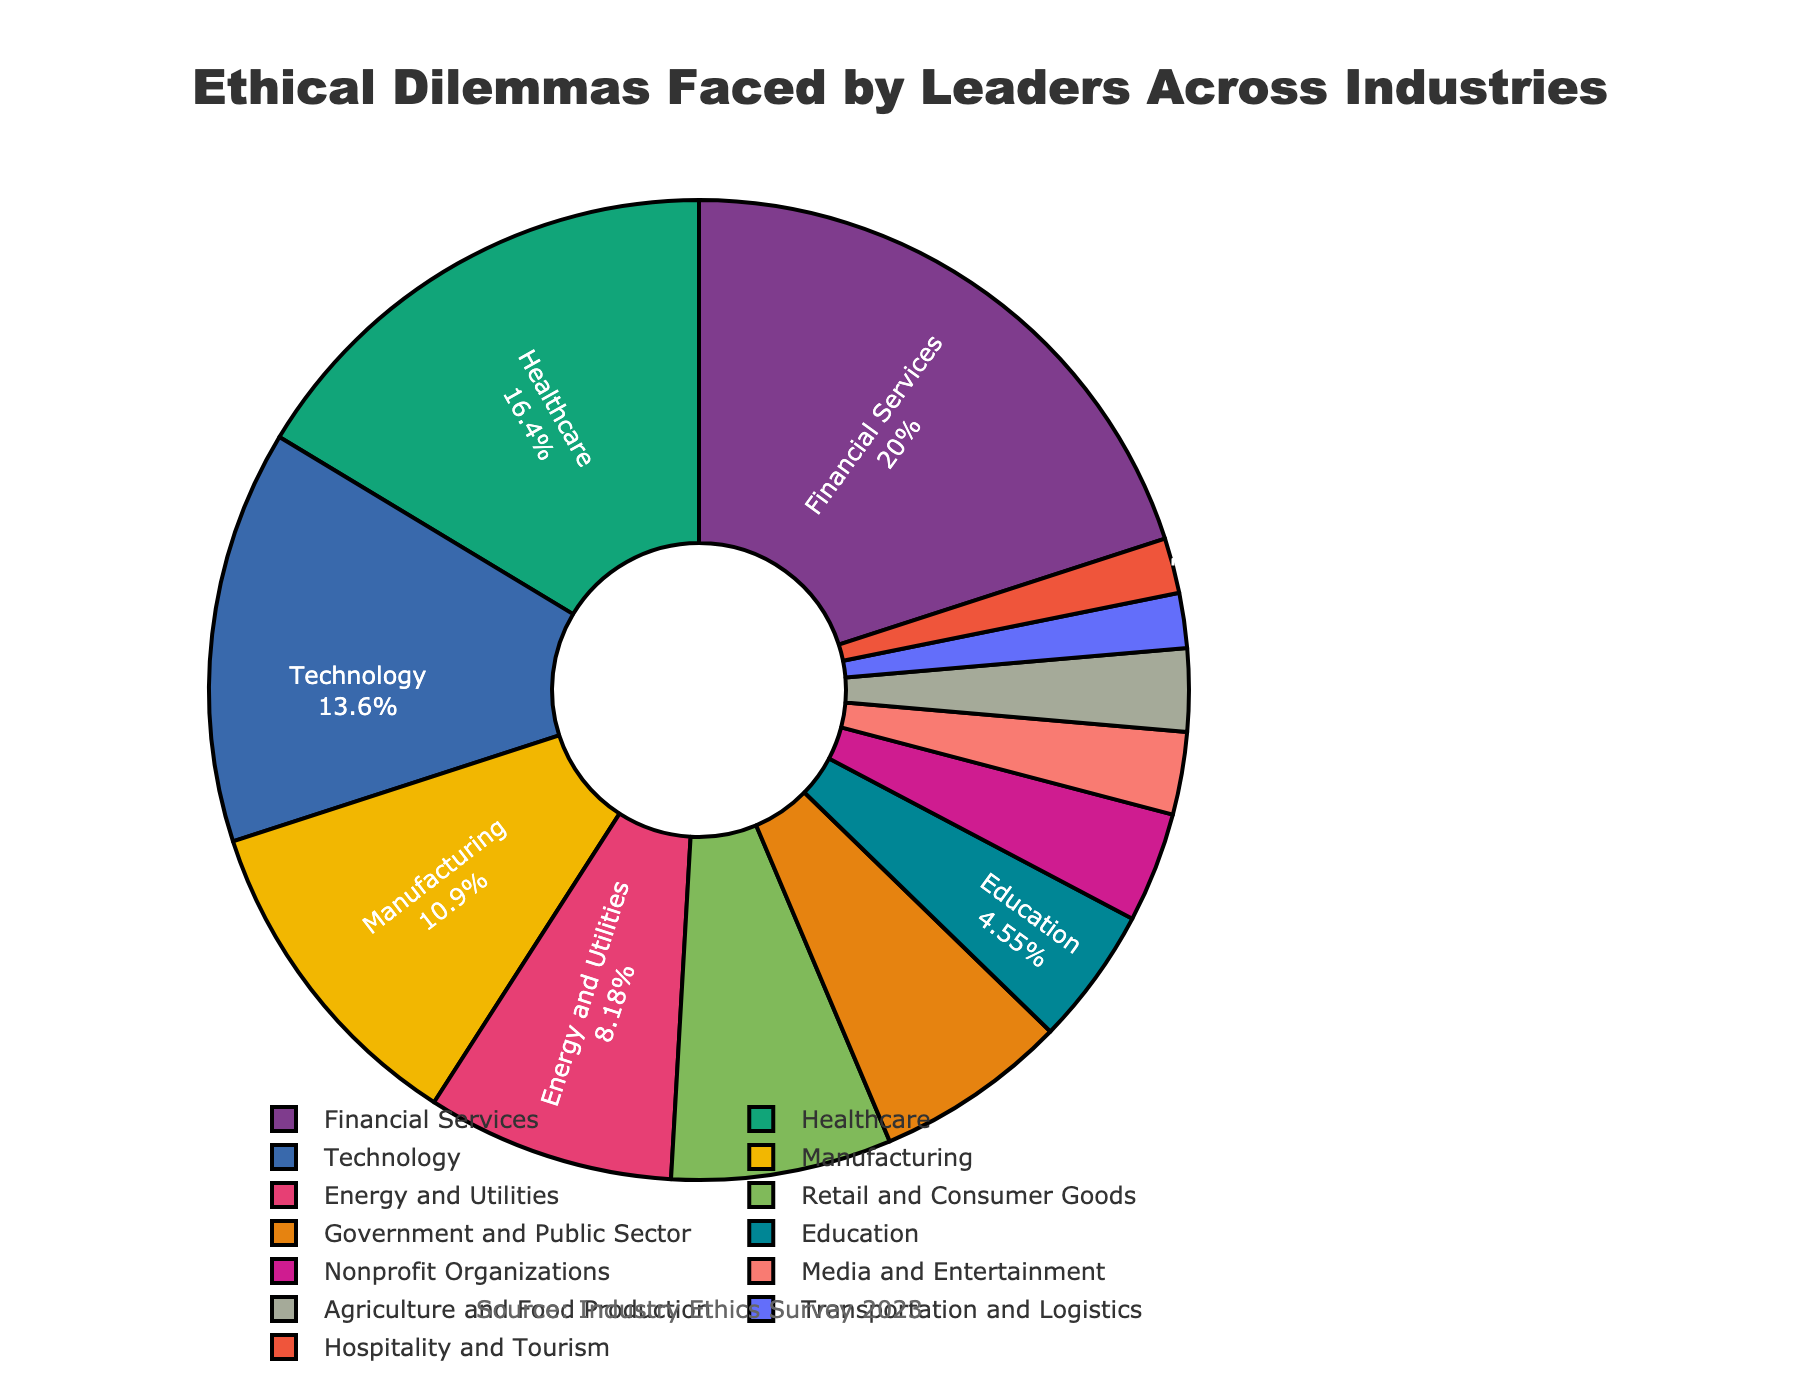Which industry sector faces the highest percentage of ethical dilemmas? The sector with the largest slice in the pie chart represents the highest percentage. By visual inspection, the Financial Services sector has the largest slice.
Answer: Financial Services How much larger is the percentage of ethical dilemmas faced by the Technology sector compared to the Education sector? Identify the percentages for both sectors: Technology (15%) and Education (5%). Subtract the smaller percentage from the larger one: 15% - 5% = 10%.
Answer: 10% What are the combined percentages of ethical dilemmas faced by the Manufacturing and Energy and Utilities sectors? Locate the percentages for both sectors: Manufacturing (12%) and Energy and Utilities (9%). Add them together: 12% + 9% = 21%.
Answer: 21% What is the average percentage of ethical dilemmas for the top three sectors? Identify the top three sectors by percentage: Financial Services (22%), Healthcare (18%), and Technology (15%). Calculate the average: (22% + 18% + 15%) / 3 = 55% / 3 = 18.33%.
Answer: 18.33% Is the prevalence of ethical dilemmas higher in private sectors (Financial Services, Healthcare, Technology, etc.) or in public/nonprofit sectors (Government and Public Sector, Education, Nonprofit Organizations)? Sum the percentages for private sectors (22% + 18% + 15% + 12% + 9% + 8%) and public/nonprofit sectors (7% + 5% + 4%). Compare the sums: 84% (private) vs. 16% (public/nonprofit).
Answer: Private sectors Which visual aspect indicates the proportion of ethical dilemmas faced by the Transportation and Logistics sector? In a pie chart, the size of each slice represents the proportion. The small slice corresponding to Transportation and Logistics, labeled 2%, shows its proportion.
Answer: Slice size What is the total percentage of ethical dilemmas faced by sectors with less than 5% each? Identify sectors with less than 5%: Nonprofit Organizations (4%), Media and Entertainment (3%), Agriculture and Food Production (3%), Transportation and Logistics (2%), Hospitality and Tourism (2%). Sum their percentages: 4% + 3% + 3% + 2% + 2% = 14%.
Answer: 14% Which sector has a smaller percentage of ethical dilemmas, Retail and Consumer Goods or Government and Public Sector? Locate and compare the percentages: Retail and Consumer Goods (8%) and Government and Public Sector (7%). Retail and Consumer Goods is larger; hence, Government and Public Sector is smaller.
Answer: Government and Public Sector 